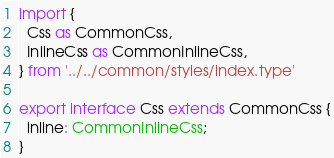Convert code to text. <code><loc_0><loc_0><loc_500><loc_500><_TypeScript_>import {
  Css as CommonCss,
  InlineCss as CommonInlineCss,
} from '../../common/styles/index.type'

export interface Css extends CommonCss {
  inline: CommonInlineCss;
}
</code> 